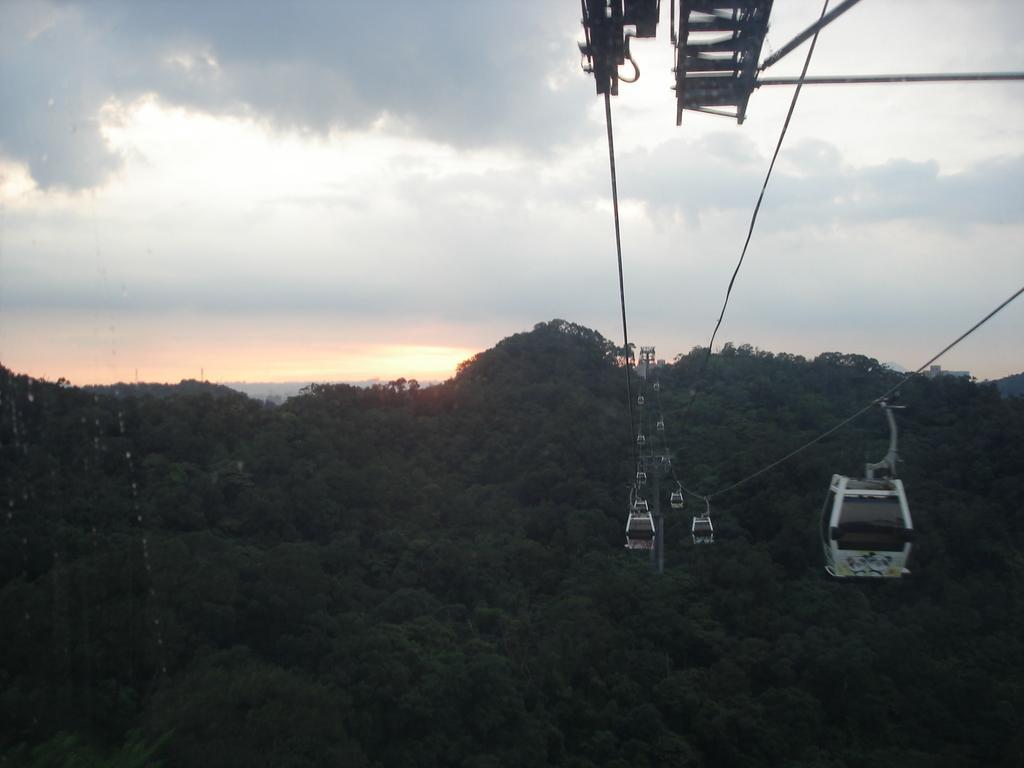Can you describe this image briefly? In this image there is a ropeway and we can see trees. In the background there are hills and sky. 